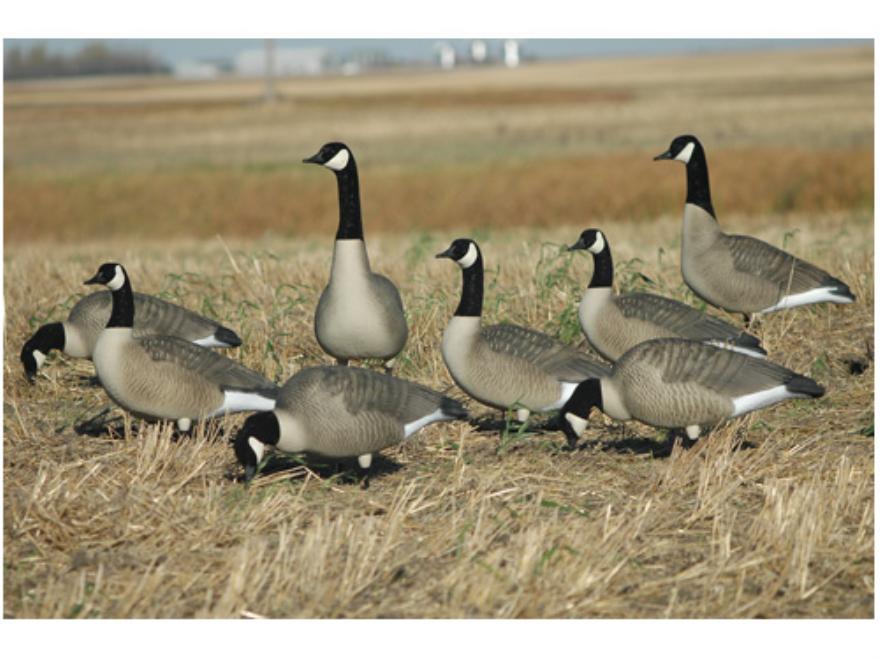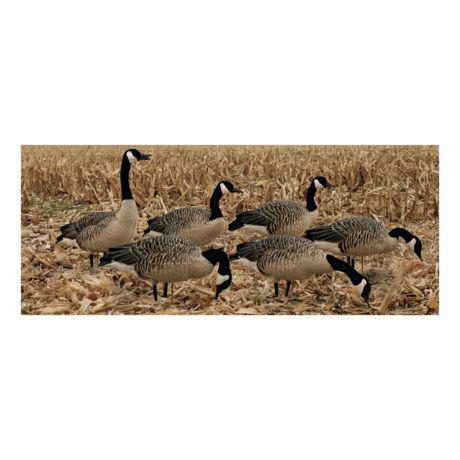The first image is the image on the left, the second image is the image on the right. Evaluate the accuracy of this statement regarding the images: "Ducks in the left image are in water.". Is it true? Answer yes or no. No. The first image is the image on the left, the second image is the image on the right. Evaluate the accuracy of this statement regarding the images: "Both images show a flock of canada geese, but in only one of the images are the geese in water.". Is it true? Answer yes or no. No. 